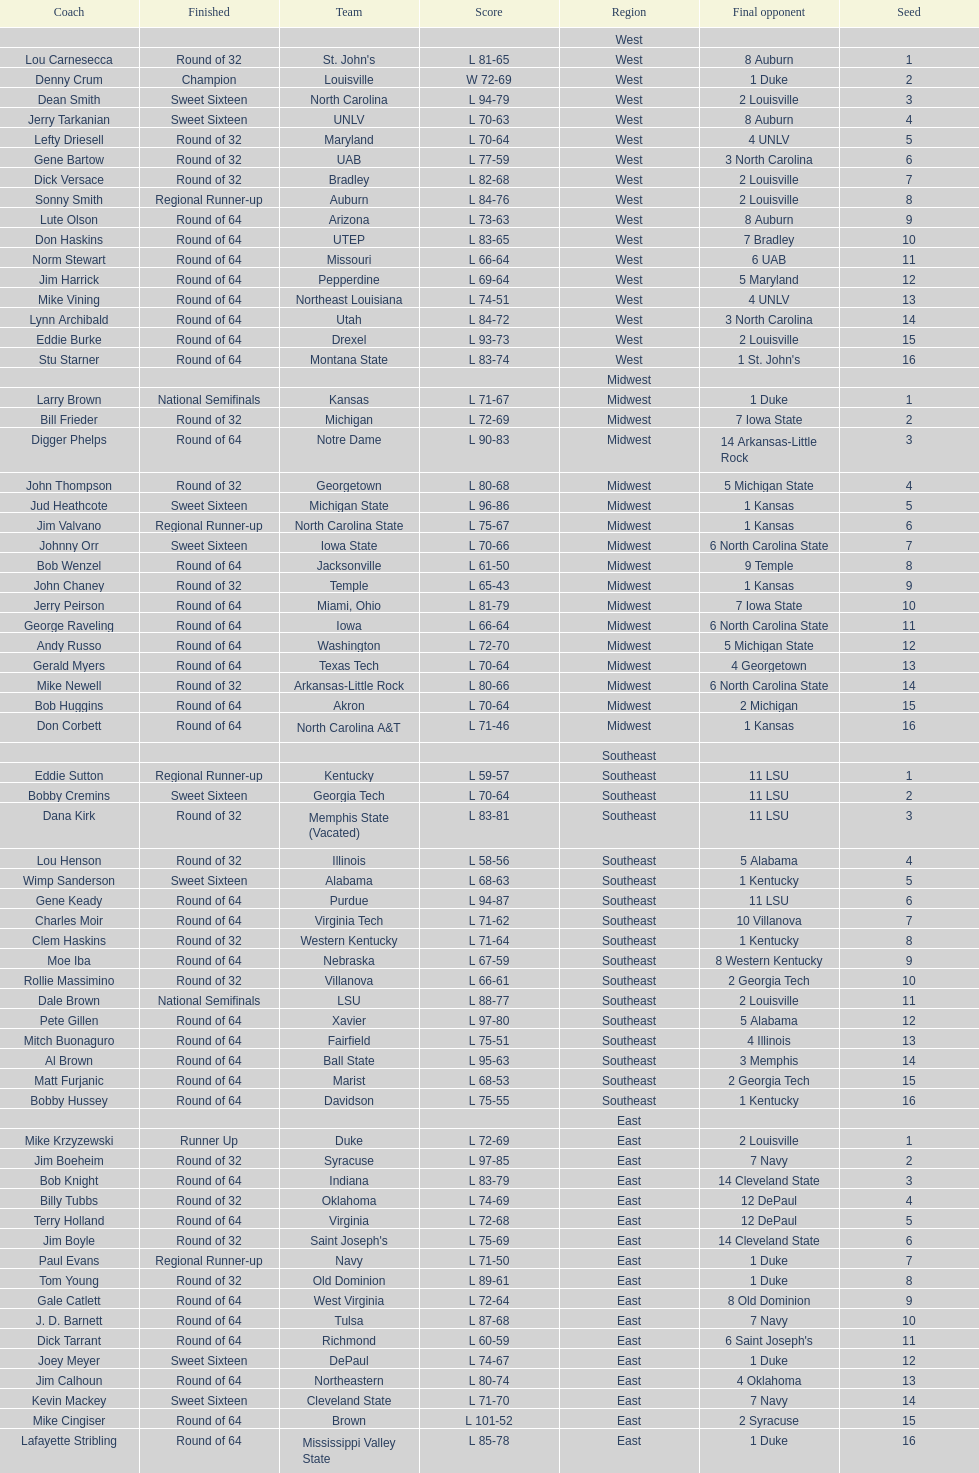I'm looking to parse the entire table for insights. Could you assist me with that? {'header': ['Coach', 'Finished', 'Team', 'Score', 'Region', 'Final opponent', 'Seed'], 'rows': [['', '', '', '', 'West', '', ''], ['Lou Carnesecca', 'Round of 32', "St. John's", 'L 81-65', 'West', '8 Auburn', '1'], ['Denny Crum', 'Champion', 'Louisville', 'W 72-69', 'West', '1 Duke', '2'], ['Dean Smith', 'Sweet Sixteen', 'North Carolina', 'L 94-79', 'West', '2 Louisville', '3'], ['Jerry Tarkanian', 'Sweet Sixteen', 'UNLV', 'L 70-63', 'West', '8 Auburn', '4'], ['Lefty Driesell', 'Round of 32', 'Maryland', 'L 70-64', 'West', '4 UNLV', '5'], ['Gene Bartow', 'Round of 32', 'UAB', 'L 77-59', 'West', '3 North Carolina', '6'], ['Dick Versace', 'Round of 32', 'Bradley', 'L 82-68', 'West', '2 Louisville', '7'], ['Sonny Smith', 'Regional Runner-up', 'Auburn', 'L 84-76', 'West', '2 Louisville', '8'], ['Lute Olson', 'Round of 64', 'Arizona', 'L 73-63', 'West', '8 Auburn', '9'], ['Don Haskins', 'Round of 64', 'UTEP', 'L 83-65', 'West', '7 Bradley', '10'], ['Norm Stewart', 'Round of 64', 'Missouri', 'L 66-64', 'West', '6 UAB', '11'], ['Jim Harrick', 'Round of 64', 'Pepperdine', 'L 69-64', 'West', '5 Maryland', '12'], ['Mike Vining', 'Round of 64', 'Northeast Louisiana', 'L 74-51', 'West', '4 UNLV', '13'], ['Lynn Archibald', 'Round of 64', 'Utah', 'L 84-72', 'West', '3 North Carolina', '14'], ['Eddie Burke', 'Round of 64', 'Drexel', 'L 93-73', 'West', '2 Louisville', '15'], ['Stu Starner', 'Round of 64', 'Montana State', 'L 83-74', 'West', "1 St. John's", '16'], ['', '', '', '', 'Midwest', '', ''], ['Larry Brown', 'National Semifinals', 'Kansas', 'L 71-67', 'Midwest', '1 Duke', '1'], ['Bill Frieder', 'Round of 32', 'Michigan', 'L 72-69', 'Midwest', '7 Iowa State', '2'], ['Digger Phelps', 'Round of 64', 'Notre Dame', 'L 90-83', 'Midwest', '14 Arkansas-Little Rock', '3'], ['John Thompson', 'Round of 32', 'Georgetown', 'L 80-68', 'Midwest', '5 Michigan State', '4'], ['Jud Heathcote', 'Sweet Sixteen', 'Michigan State', 'L 96-86', 'Midwest', '1 Kansas', '5'], ['Jim Valvano', 'Regional Runner-up', 'North Carolina State', 'L 75-67', 'Midwest', '1 Kansas', '6'], ['Johnny Orr', 'Sweet Sixteen', 'Iowa State', 'L 70-66', 'Midwest', '6 North Carolina State', '7'], ['Bob Wenzel', 'Round of 64', 'Jacksonville', 'L 61-50', 'Midwest', '9 Temple', '8'], ['John Chaney', 'Round of 32', 'Temple', 'L 65-43', 'Midwest', '1 Kansas', '9'], ['Jerry Peirson', 'Round of 64', 'Miami, Ohio', 'L 81-79', 'Midwest', '7 Iowa State', '10'], ['George Raveling', 'Round of 64', 'Iowa', 'L 66-64', 'Midwest', '6 North Carolina State', '11'], ['Andy Russo', 'Round of 64', 'Washington', 'L 72-70', 'Midwest', '5 Michigan State', '12'], ['Gerald Myers', 'Round of 64', 'Texas Tech', 'L 70-64', 'Midwest', '4 Georgetown', '13'], ['Mike Newell', 'Round of 32', 'Arkansas-Little Rock', 'L 80-66', 'Midwest', '6 North Carolina State', '14'], ['Bob Huggins', 'Round of 64', 'Akron', 'L 70-64', 'Midwest', '2 Michigan', '15'], ['Don Corbett', 'Round of 64', 'North Carolina A&T', 'L 71-46', 'Midwest', '1 Kansas', '16'], ['', '', '', '', 'Southeast', '', ''], ['Eddie Sutton', 'Regional Runner-up', 'Kentucky', 'L 59-57', 'Southeast', '11 LSU', '1'], ['Bobby Cremins', 'Sweet Sixteen', 'Georgia Tech', 'L 70-64', 'Southeast', '11 LSU', '2'], ['Dana Kirk', 'Round of 32', 'Memphis State (Vacated)', 'L 83-81', 'Southeast', '11 LSU', '3'], ['Lou Henson', 'Round of 32', 'Illinois', 'L 58-56', 'Southeast', '5 Alabama', '4'], ['Wimp Sanderson', 'Sweet Sixteen', 'Alabama', 'L 68-63', 'Southeast', '1 Kentucky', '5'], ['Gene Keady', 'Round of 64', 'Purdue', 'L 94-87', 'Southeast', '11 LSU', '6'], ['Charles Moir', 'Round of 64', 'Virginia Tech', 'L 71-62', 'Southeast', '10 Villanova', '7'], ['Clem Haskins', 'Round of 32', 'Western Kentucky', 'L 71-64', 'Southeast', '1 Kentucky', '8'], ['Moe Iba', 'Round of 64', 'Nebraska', 'L 67-59', 'Southeast', '8 Western Kentucky', '9'], ['Rollie Massimino', 'Round of 32', 'Villanova', 'L 66-61', 'Southeast', '2 Georgia Tech', '10'], ['Dale Brown', 'National Semifinals', 'LSU', 'L 88-77', 'Southeast', '2 Louisville', '11'], ['Pete Gillen', 'Round of 64', 'Xavier', 'L 97-80', 'Southeast', '5 Alabama', '12'], ['Mitch Buonaguro', 'Round of 64', 'Fairfield', 'L 75-51', 'Southeast', '4 Illinois', '13'], ['Al Brown', 'Round of 64', 'Ball State', 'L 95-63', 'Southeast', '3 Memphis', '14'], ['Matt Furjanic', 'Round of 64', 'Marist', 'L 68-53', 'Southeast', '2 Georgia Tech', '15'], ['Bobby Hussey', 'Round of 64', 'Davidson', 'L 75-55', 'Southeast', '1 Kentucky', '16'], ['', '', '', '', 'East', '', ''], ['Mike Krzyzewski', 'Runner Up', 'Duke', 'L 72-69', 'East', '2 Louisville', '1'], ['Jim Boeheim', 'Round of 32', 'Syracuse', 'L 97-85', 'East', '7 Navy', '2'], ['Bob Knight', 'Round of 64', 'Indiana', 'L 83-79', 'East', '14 Cleveland State', '3'], ['Billy Tubbs', 'Round of 32', 'Oklahoma', 'L 74-69', 'East', '12 DePaul', '4'], ['Terry Holland', 'Round of 64', 'Virginia', 'L 72-68', 'East', '12 DePaul', '5'], ['Jim Boyle', 'Round of 32', "Saint Joseph's", 'L 75-69', 'East', '14 Cleveland State', '6'], ['Paul Evans', 'Regional Runner-up', 'Navy', 'L 71-50', 'East', '1 Duke', '7'], ['Tom Young', 'Round of 32', 'Old Dominion', 'L 89-61', 'East', '1 Duke', '8'], ['Gale Catlett', 'Round of 64', 'West Virginia', 'L 72-64', 'East', '8 Old Dominion', '9'], ['J. D. Barnett', 'Round of 64', 'Tulsa', 'L 87-68', 'East', '7 Navy', '10'], ['Dick Tarrant', 'Round of 64', 'Richmond', 'L 60-59', 'East', "6 Saint Joseph's", '11'], ['Joey Meyer', 'Sweet Sixteen', 'DePaul', 'L 74-67', 'East', '1 Duke', '12'], ['Jim Calhoun', 'Round of 64', 'Northeastern', 'L 80-74', 'East', '4 Oklahoma', '13'], ['Kevin Mackey', 'Sweet Sixteen', 'Cleveland State', 'L 71-70', 'East', '7 Navy', '14'], ['Mike Cingiser', 'Round of 64', 'Brown', 'L 101-52', 'East', '2 Syracuse', '15'], ['Lafayette Stribling', 'Round of 64', 'Mississippi Valley State', 'L 85-78', 'East', '1 Duke', '16']]} Who was the only champion? Louisville. 